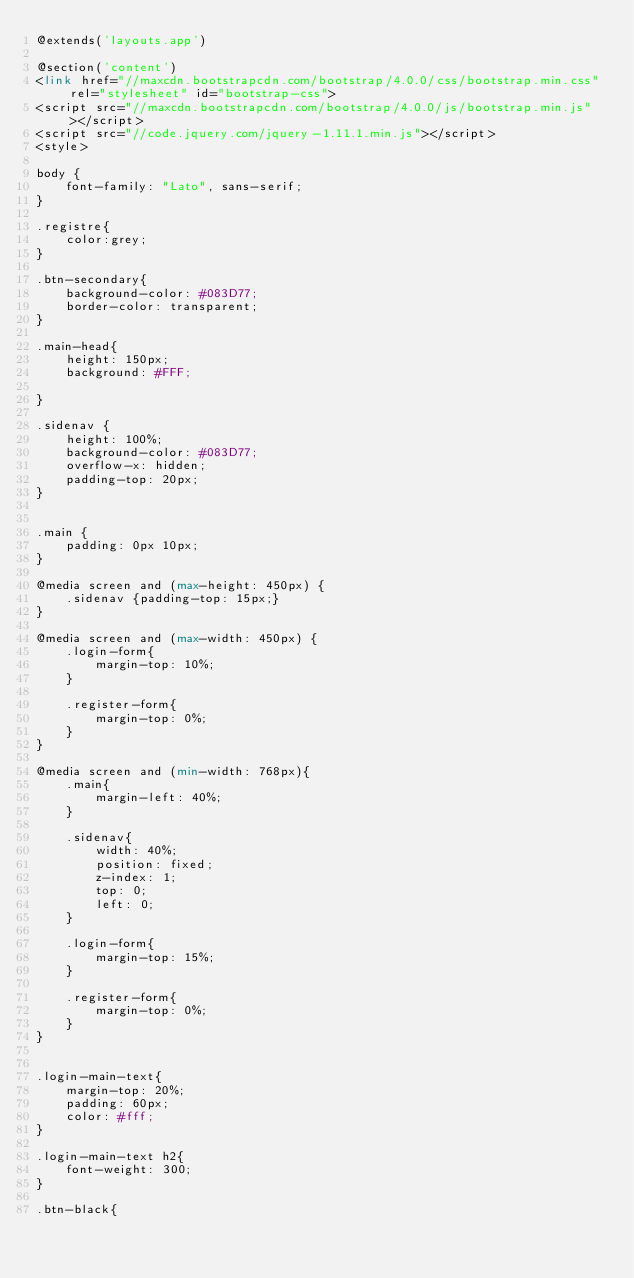Convert code to text. <code><loc_0><loc_0><loc_500><loc_500><_PHP_>@extends('layouts.app')

@section('content')
<link href="//maxcdn.bootstrapcdn.com/bootstrap/4.0.0/css/bootstrap.min.css" rel="stylesheet" id="bootstrap-css">
<script src="//maxcdn.bootstrapcdn.com/bootstrap/4.0.0/js/bootstrap.min.js"></script>
<script src="//code.jquery.com/jquery-1.11.1.min.js"></script>
<style>
  
body {
    font-family: "Lato", sans-serif;
}

.registre{
    color:grey;
}

.btn-secondary{
    background-color: #083D77;
    border-color: transparent;
}

.main-head{
    height: 150px;
    background: #FFF;
   
}

.sidenav {
    height: 100%;
    background-color: #083D77;
    overflow-x: hidden;
    padding-top: 20px;
}


.main {
    padding: 0px 10px;
}

@media screen and (max-height: 450px) {
    .sidenav {padding-top: 15px;}
}

@media screen and (max-width: 450px) {
    .login-form{
        margin-top: 10%;
    }

    .register-form{
        margin-top: 0%;
    }
}

@media screen and (min-width: 768px){
    .main{
        margin-left: 40%; 
    }

    .sidenav{
        width: 40%;
        position: fixed;
        z-index: 1;
        top: 0;
        left: 0;
    }

    .login-form{
        margin-top: 15%;
    }

    .register-form{
        margin-top: 0%;
    }
}


.login-main-text{
    margin-top: 20%;
    padding: 60px;
    color: #fff;
}

.login-main-text h2{
    font-weight: 300;
}

.btn-black{</code> 